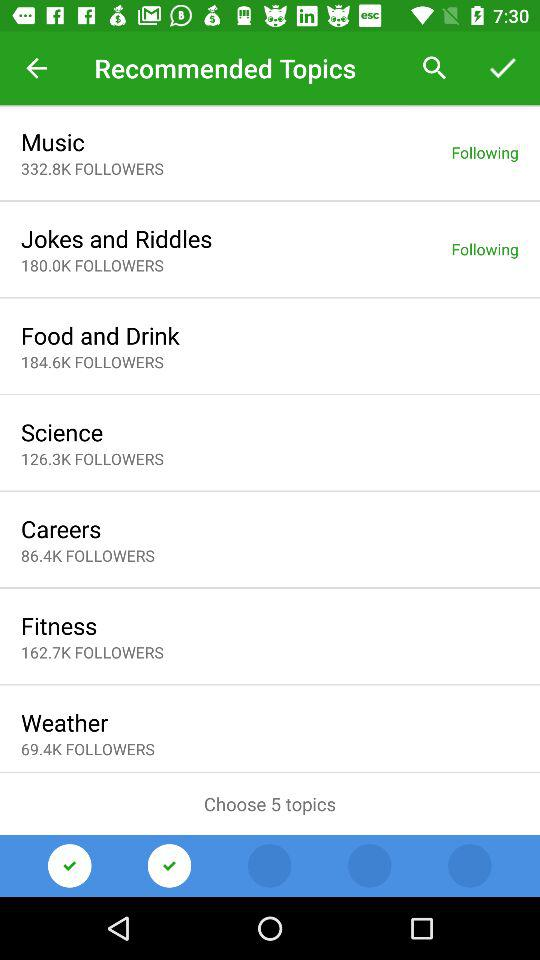Which topic has 184.6k followers? The topic is "Food and Drink". 